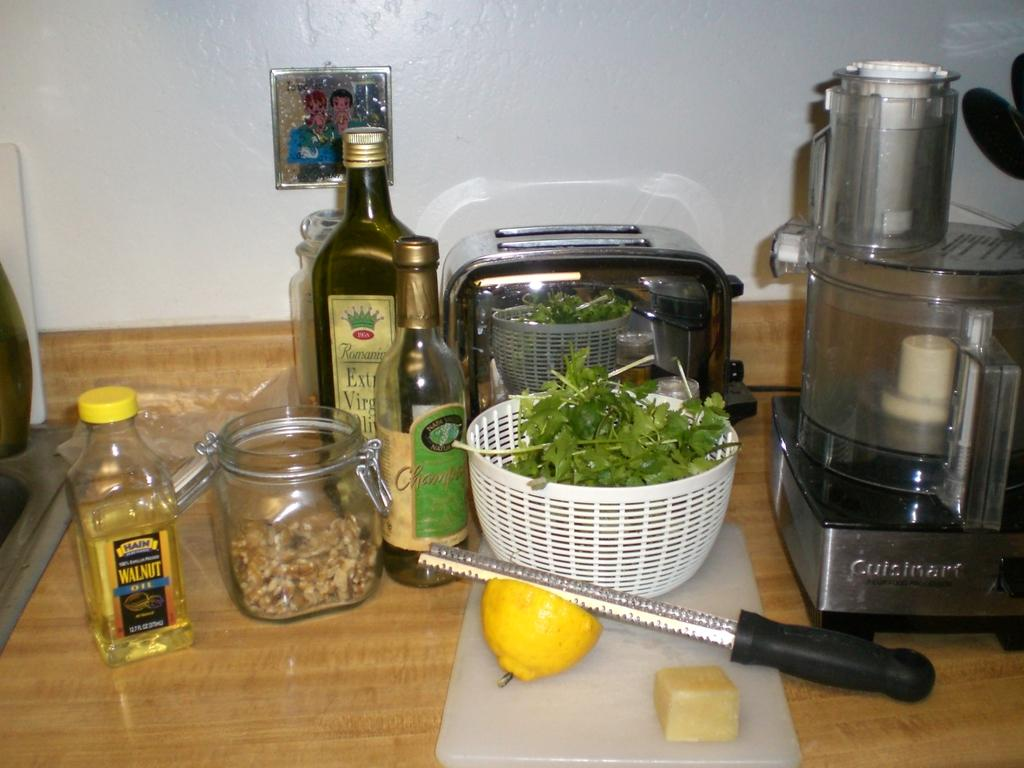<image>
Share a concise interpretation of the image provided. kitchen countertop with bottles of walnut oil, extra virgin olive oil, another bottle, toaster, food processor, lemon, greens, and other things 